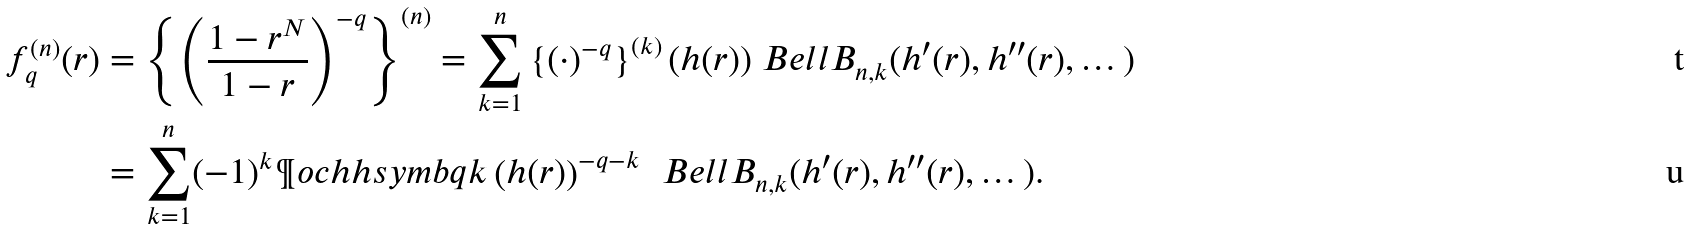<formula> <loc_0><loc_0><loc_500><loc_500>f _ { q } ^ { ( n ) } ( r ) & = \left \{ \left ( \frac { 1 - r ^ { N } } { 1 - r } \right ) ^ { - q } \right \} ^ { ( n ) } = \sum _ { k = 1 } ^ { n } \left \{ ( \cdot ) ^ { - q } \right \} ^ { ( k ) } ( h ( r ) ) \ B e l l B _ { n , k } ( h ^ { \prime } ( r ) , h ^ { \prime \prime } ( r ) , \dots ) \\ & = \sum _ { k = 1 } ^ { n } ( - 1 ) ^ { k } \P o c h h s y m b { q } { k } \left ( h ( r ) \right ) ^ { - q - k } \, \ B e l l B _ { n , k } ( h ^ { \prime } ( r ) , h ^ { \prime \prime } ( r ) , \dots ) .</formula> 